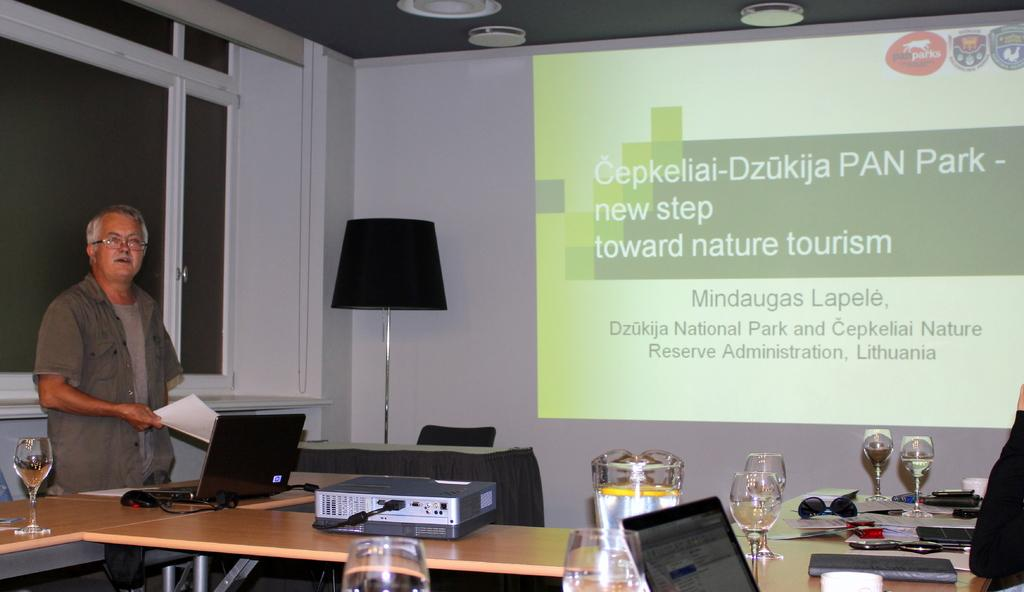<image>
Render a clear and concise summary of the photo. A man is standing next to a laptop that is projected onto a screen mentioning tourism. 